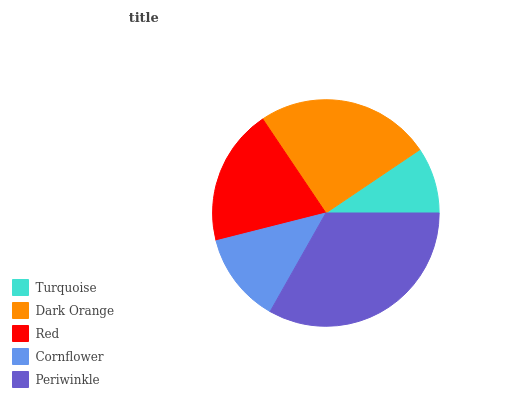Is Turquoise the minimum?
Answer yes or no. Yes. Is Periwinkle the maximum?
Answer yes or no. Yes. Is Dark Orange the minimum?
Answer yes or no. No. Is Dark Orange the maximum?
Answer yes or no. No. Is Dark Orange greater than Turquoise?
Answer yes or no. Yes. Is Turquoise less than Dark Orange?
Answer yes or no. Yes. Is Turquoise greater than Dark Orange?
Answer yes or no. No. Is Dark Orange less than Turquoise?
Answer yes or no. No. Is Red the high median?
Answer yes or no. Yes. Is Red the low median?
Answer yes or no. Yes. Is Turquoise the high median?
Answer yes or no. No. Is Cornflower the low median?
Answer yes or no. No. 